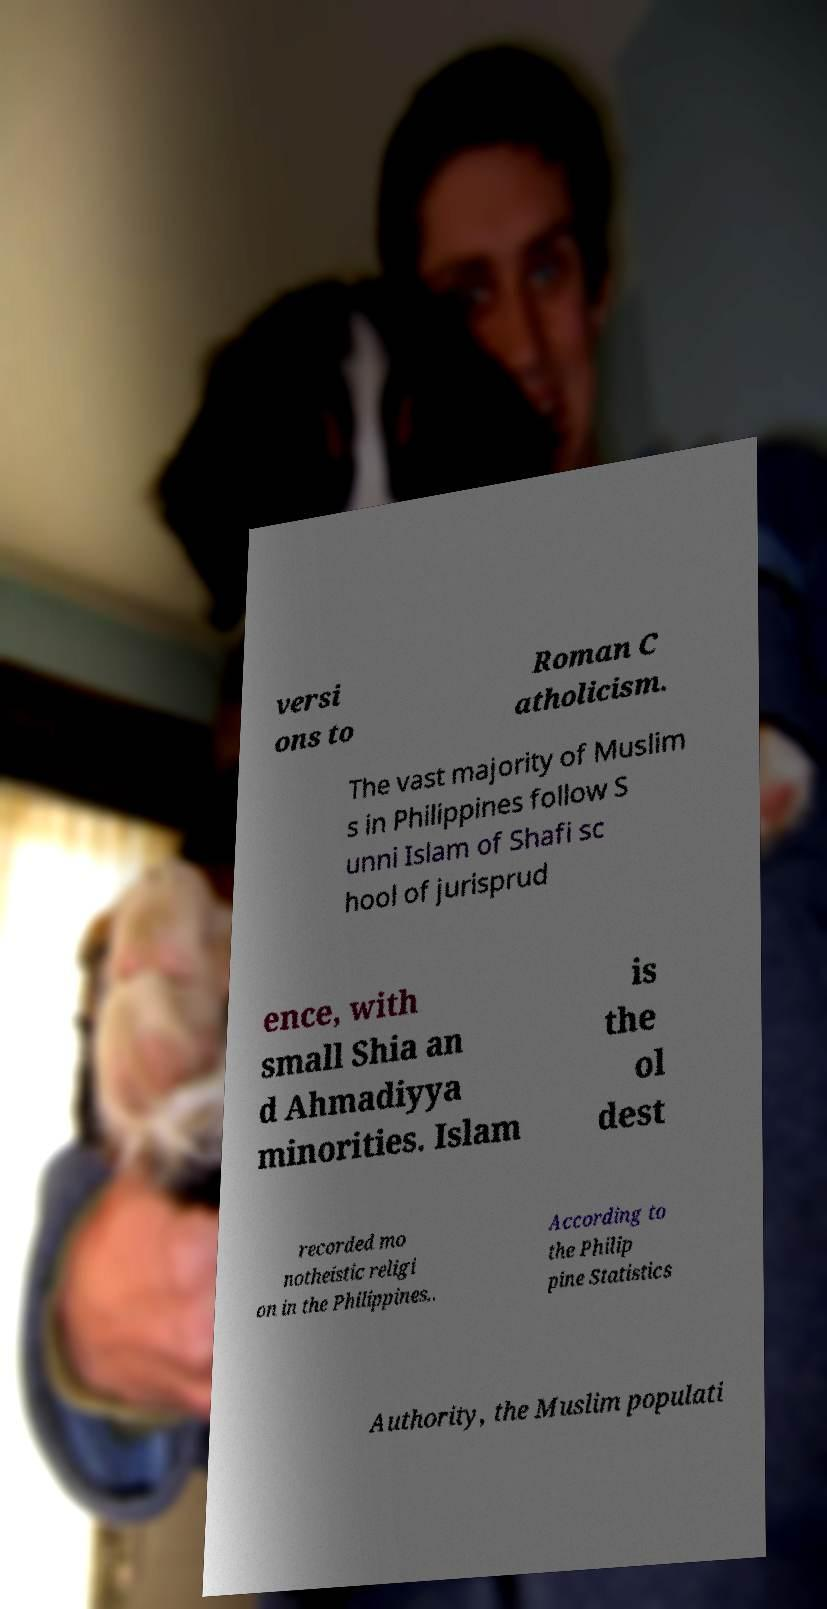Could you extract and type out the text from this image? versi ons to Roman C atholicism. The vast majority of Muslim s in Philippines follow S unni Islam of Shafi sc hool of jurisprud ence, with small Shia an d Ahmadiyya minorities. Islam is the ol dest recorded mo notheistic religi on in the Philippines.. According to the Philip pine Statistics Authority, the Muslim populati 